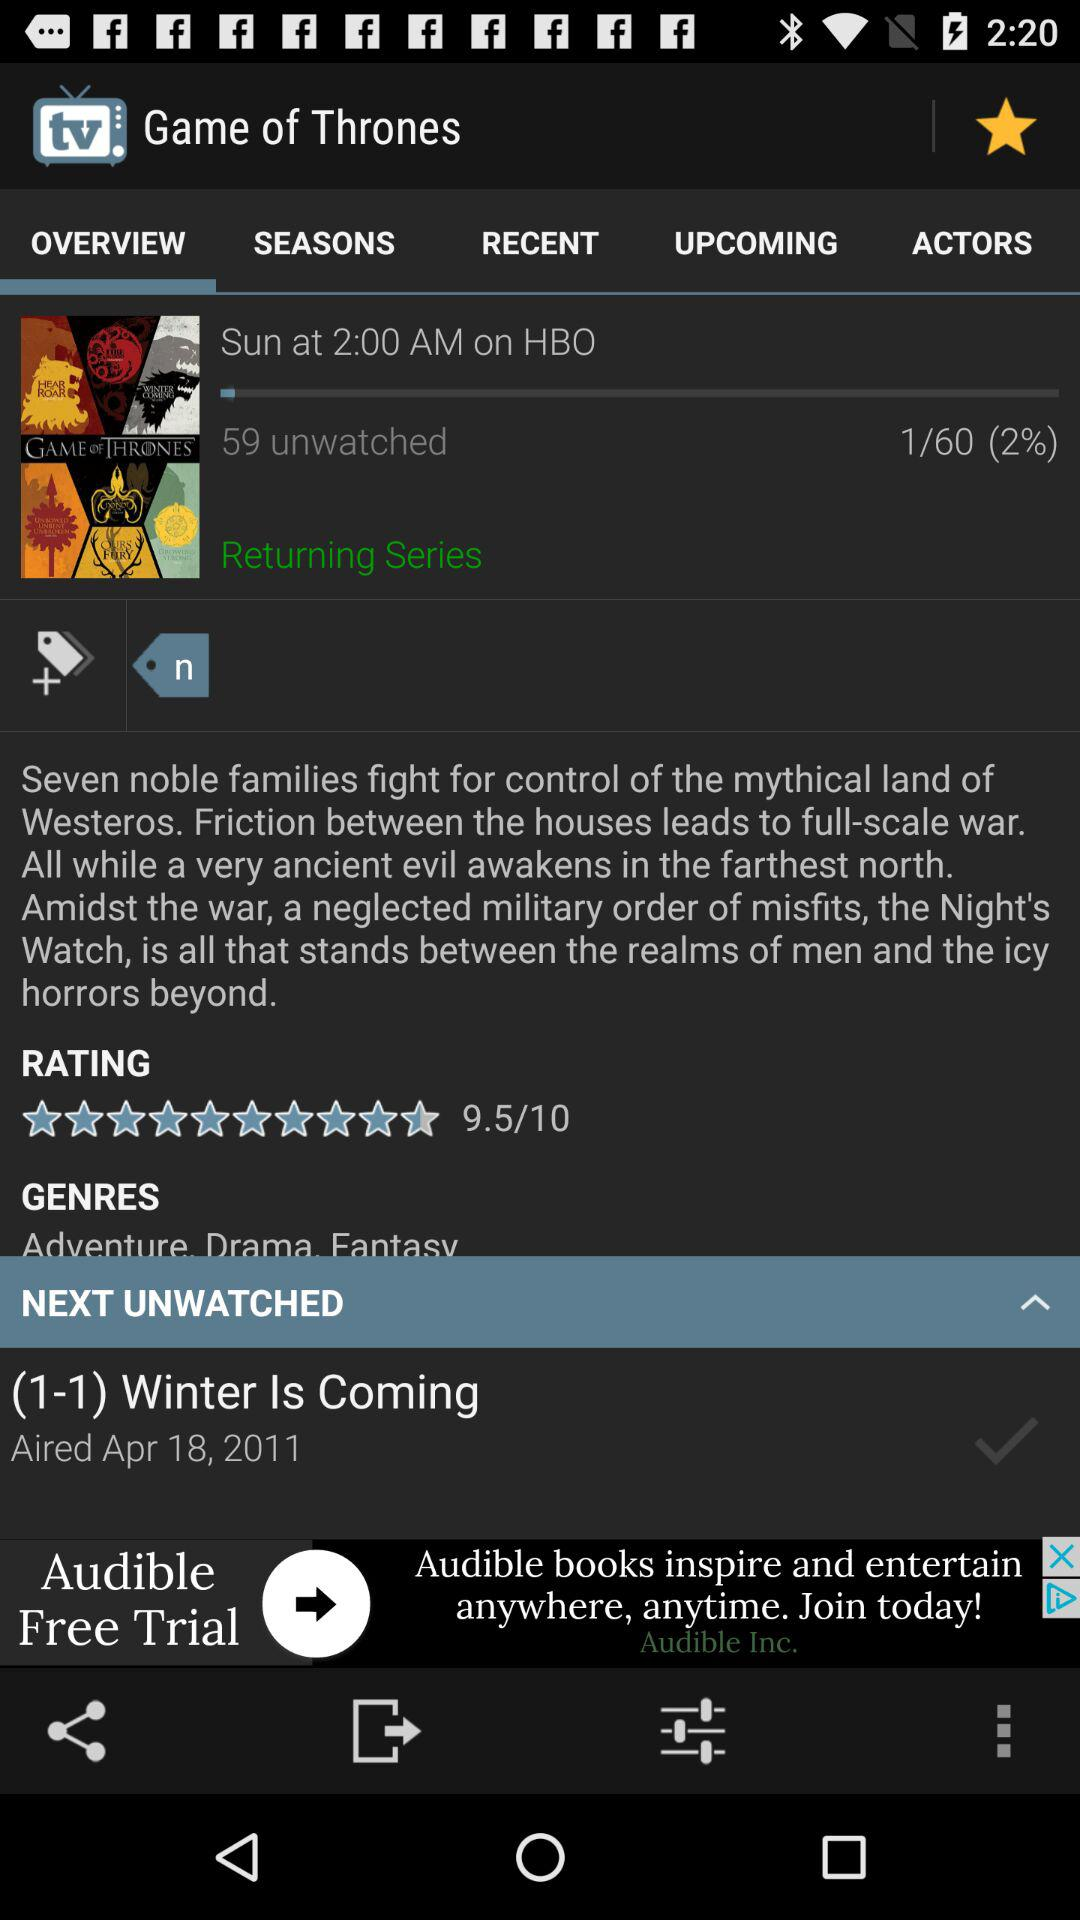What is the average rating of Game of Thrones?
Answer the question using a single word or phrase. 9.5/10 